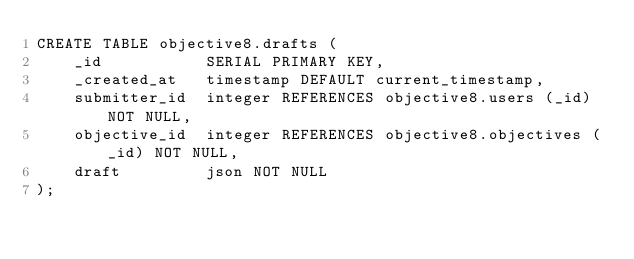Convert code to text. <code><loc_0><loc_0><loc_500><loc_500><_SQL_>CREATE TABLE objective8.drafts (
    _id           SERIAL PRIMARY KEY,
    _created_at   timestamp DEFAULT current_timestamp,
    submitter_id  integer REFERENCES objective8.users (_id) NOT NULL,
    objective_id  integer REFERENCES objective8.objectives (_id) NOT NULL,
    draft         json NOT NULL
);
</code> 